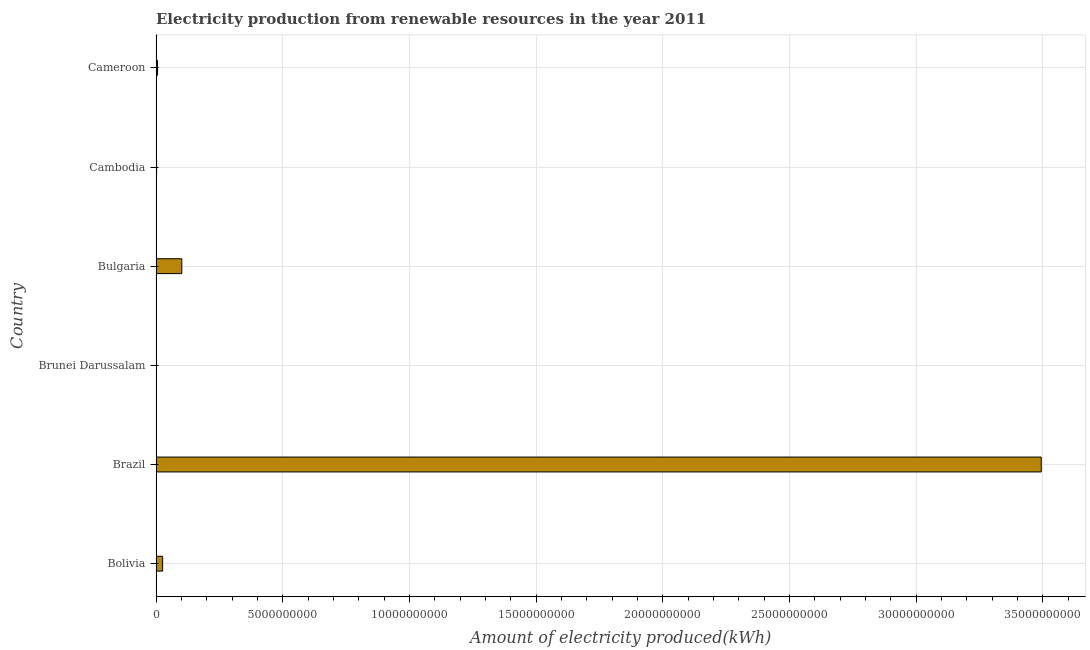What is the title of the graph?
Your response must be concise. Electricity production from renewable resources in the year 2011. What is the label or title of the X-axis?
Give a very brief answer. Amount of electricity produced(kWh). What is the label or title of the Y-axis?
Give a very brief answer. Country. What is the amount of electricity produced in Bulgaria?
Offer a very short reply. 1.02e+09. Across all countries, what is the maximum amount of electricity produced?
Your answer should be compact. 3.49e+1. In which country was the amount of electricity produced minimum?
Offer a terse response. Brunei Darussalam. What is the sum of the amount of electricity produced?
Give a very brief answer. 3.63e+1. What is the difference between the amount of electricity produced in Bulgaria and Cambodia?
Offer a very short reply. 9.95e+08. What is the average amount of electricity produced per country?
Your answer should be compact. 6.05e+09. What is the median amount of electricity produced?
Give a very brief answer. 1.61e+08. What is the ratio of the amount of electricity produced in Bolivia to that in Brazil?
Offer a very short reply. 0.01. Is the amount of electricity produced in Bolivia less than that in Cameroon?
Keep it short and to the point. No. What is the difference between the highest and the second highest amount of electricity produced?
Keep it short and to the point. 3.39e+1. What is the difference between the highest and the lowest amount of electricity produced?
Make the answer very short. 3.49e+1. In how many countries, is the amount of electricity produced greater than the average amount of electricity produced taken over all countries?
Ensure brevity in your answer.  1. How many bars are there?
Keep it short and to the point. 6. How many countries are there in the graph?
Offer a very short reply. 6. What is the difference between two consecutive major ticks on the X-axis?
Provide a succinct answer. 5.00e+09. What is the Amount of electricity produced(kWh) of Bolivia?
Make the answer very short. 2.61e+08. What is the Amount of electricity produced(kWh) in Brazil?
Offer a very short reply. 3.49e+1. What is the Amount of electricity produced(kWh) in Bulgaria?
Ensure brevity in your answer.  1.02e+09. What is the Amount of electricity produced(kWh) of Cambodia?
Offer a very short reply. 2.30e+07. What is the Amount of electricity produced(kWh) in Cameroon?
Provide a short and direct response. 6.10e+07. What is the difference between the Amount of electricity produced(kWh) in Bolivia and Brazil?
Your response must be concise. -3.47e+1. What is the difference between the Amount of electricity produced(kWh) in Bolivia and Brunei Darussalam?
Give a very brief answer. 2.59e+08. What is the difference between the Amount of electricity produced(kWh) in Bolivia and Bulgaria?
Offer a very short reply. -7.57e+08. What is the difference between the Amount of electricity produced(kWh) in Bolivia and Cambodia?
Your answer should be compact. 2.38e+08. What is the difference between the Amount of electricity produced(kWh) in Brazil and Brunei Darussalam?
Your response must be concise. 3.49e+1. What is the difference between the Amount of electricity produced(kWh) in Brazil and Bulgaria?
Your answer should be compact. 3.39e+1. What is the difference between the Amount of electricity produced(kWh) in Brazil and Cambodia?
Offer a very short reply. 3.49e+1. What is the difference between the Amount of electricity produced(kWh) in Brazil and Cameroon?
Provide a short and direct response. 3.49e+1. What is the difference between the Amount of electricity produced(kWh) in Brunei Darussalam and Bulgaria?
Provide a succinct answer. -1.02e+09. What is the difference between the Amount of electricity produced(kWh) in Brunei Darussalam and Cambodia?
Offer a terse response. -2.10e+07. What is the difference between the Amount of electricity produced(kWh) in Brunei Darussalam and Cameroon?
Your response must be concise. -5.90e+07. What is the difference between the Amount of electricity produced(kWh) in Bulgaria and Cambodia?
Make the answer very short. 9.95e+08. What is the difference between the Amount of electricity produced(kWh) in Bulgaria and Cameroon?
Your response must be concise. 9.57e+08. What is the difference between the Amount of electricity produced(kWh) in Cambodia and Cameroon?
Keep it short and to the point. -3.80e+07. What is the ratio of the Amount of electricity produced(kWh) in Bolivia to that in Brazil?
Offer a very short reply. 0.01. What is the ratio of the Amount of electricity produced(kWh) in Bolivia to that in Brunei Darussalam?
Ensure brevity in your answer.  130.5. What is the ratio of the Amount of electricity produced(kWh) in Bolivia to that in Bulgaria?
Offer a very short reply. 0.26. What is the ratio of the Amount of electricity produced(kWh) in Bolivia to that in Cambodia?
Provide a short and direct response. 11.35. What is the ratio of the Amount of electricity produced(kWh) in Bolivia to that in Cameroon?
Keep it short and to the point. 4.28. What is the ratio of the Amount of electricity produced(kWh) in Brazil to that in Brunei Darussalam?
Offer a terse response. 1.75e+04. What is the ratio of the Amount of electricity produced(kWh) in Brazil to that in Bulgaria?
Offer a terse response. 34.32. What is the ratio of the Amount of electricity produced(kWh) in Brazil to that in Cambodia?
Provide a succinct answer. 1519.09. What is the ratio of the Amount of electricity produced(kWh) in Brazil to that in Cameroon?
Ensure brevity in your answer.  572.77. What is the ratio of the Amount of electricity produced(kWh) in Brunei Darussalam to that in Bulgaria?
Give a very brief answer. 0. What is the ratio of the Amount of electricity produced(kWh) in Brunei Darussalam to that in Cambodia?
Your answer should be very brief. 0.09. What is the ratio of the Amount of electricity produced(kWh) in Brunei Darussalam to that in Cameroon?
Provide a short and direct response. 0.03. What is the ratio of the Amount of electricity produced(kWh) in Bulgaria to that in Cambodia?
Keep it short and to the point. 44.26. What is the ratio of the Amount of electricity produced(kWh) in Bulgaria to that in Cameroon?
Your answer should be very brief. 16.69. What is the ratio of the Amount of electricity produced(kWh) in Cambodia to that in Cameroon?
Provide a succinct answer. 0.38. 